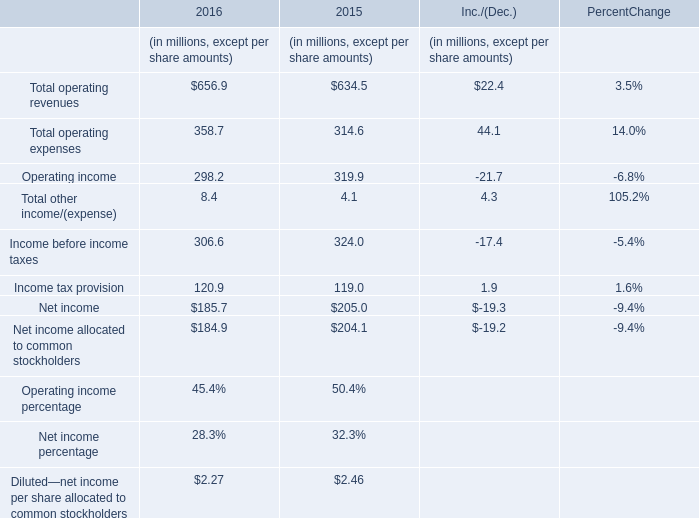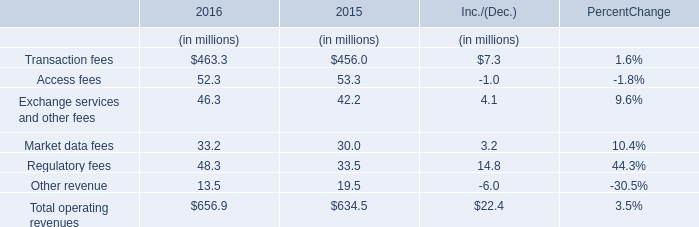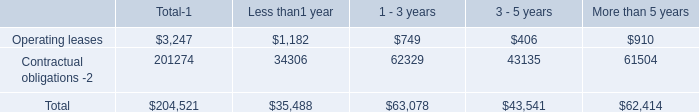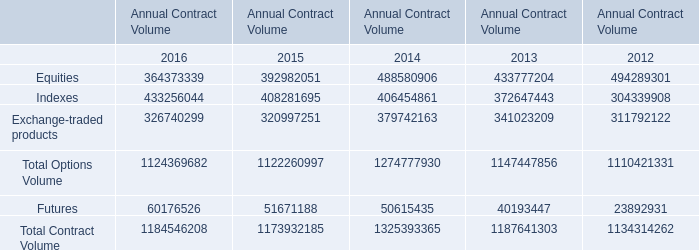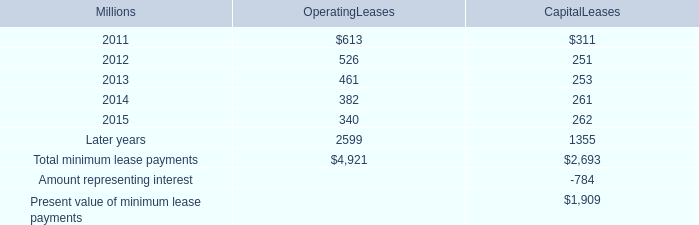what is the average rent expense for operating leases with terms exceeding one month from 2008-2010 , in millions? 
Computations: (((624 + 686) + 747) / 3)
Answer: 685.66667. 